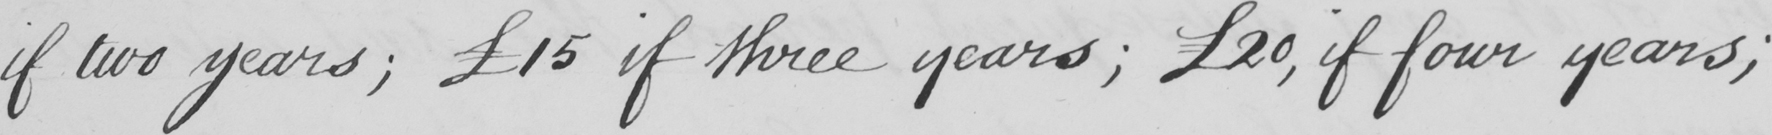Please provide the text content of this handwritten line. if two years  ;  £15 if three years  ;  £20 , if four years ; 